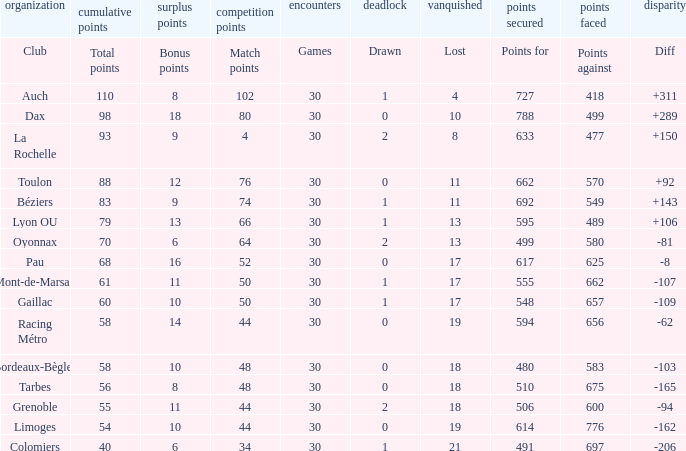What is the number of games for a club that has a value of 595 for points for? 30.0. 